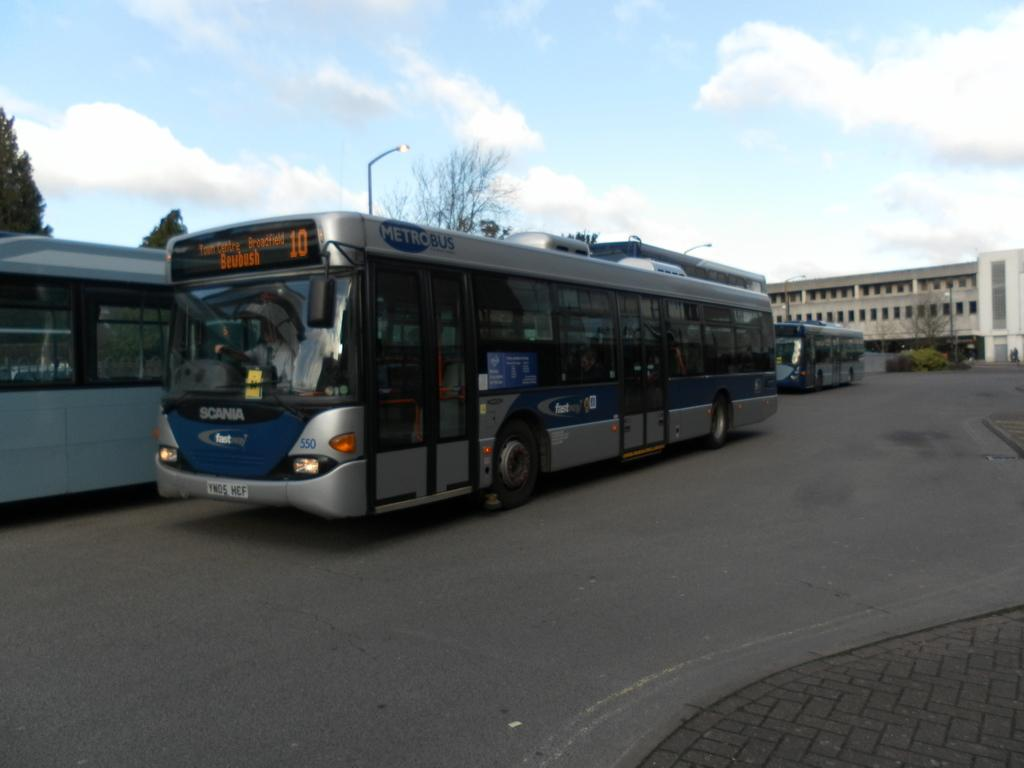What type of vehicles can be seen on the road in the image? There are buses on the road in the image. What structure is located on the right side of the image? There is a building on the right side of the image. What is visible at the top of the image? The sky is visible at the top of the image. Where is the nest of birds located in the image? There is no nest of birds present in the image. What type of zipper can be seen on the building in the image? There is no zipper visible on the building in the image. 